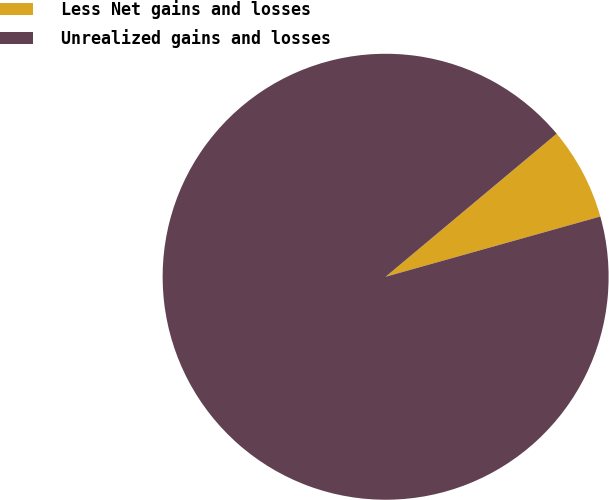Convert chart. <chart><loc_0><loc_0><loc_500><loc_500><pie_chart><fcel>Less Net gains and losses<fcel>Unrealized gains and losses<nl><fcel>6.73%<fcel>93.27%<nl></chart> 